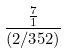<formula> <loc_0><loc_0><loc_500><loc_500>\frac { \frac { 7 } { 1 } } { ( 2 / 3 5 2 ) }</formula> 